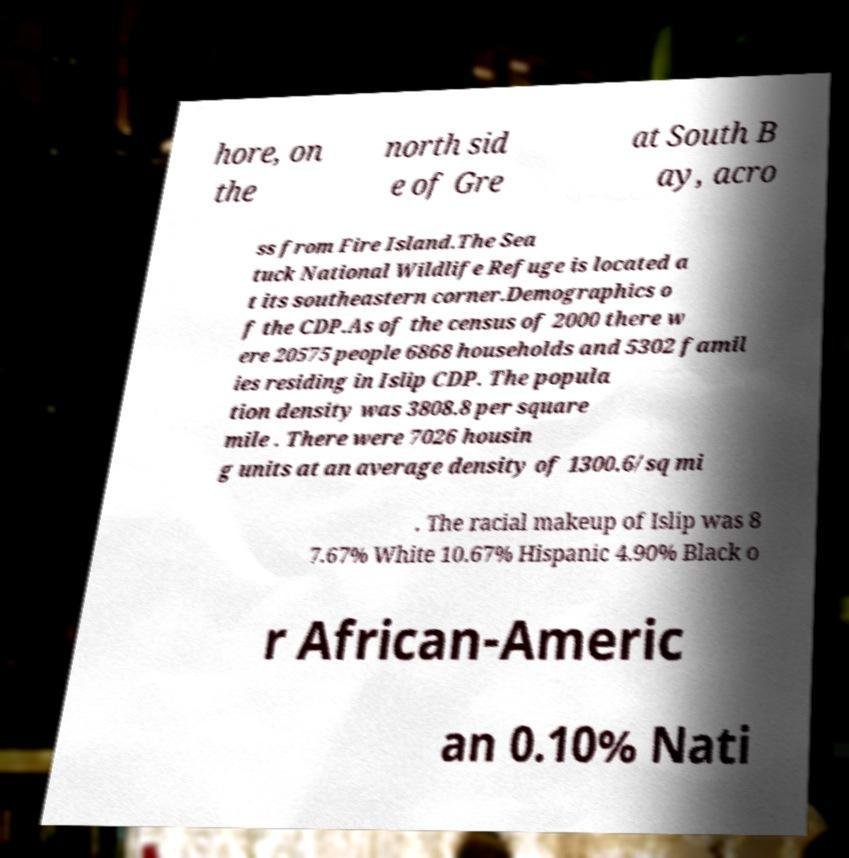Can you accurately transcribe the text from the provided image for me? hore, on the north sid e of Gre at South B ay, acro ss from Fire Island.The Sea tuck National Wildlife Refuge is located a t its southeastern corner.Demographics o f the CDP.As of the census of 2000 there w ere 20575 people 6868 households and 5302 famil ies residing in Islip CDP. The popula tion density was 3808.8 per square mile . There were 7026 housin g units at an average density of 1300.6/sq mi . The racial makeup of Islip was 8 7.67% White 10.67% Hispanic 4.90% Black o r African-Americ an 0.10% Nati 